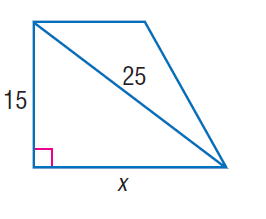Question: Find x.
Choices:
A. 10
B. 15
C. 20
D. 25
Answer with the letter. Answer: C 